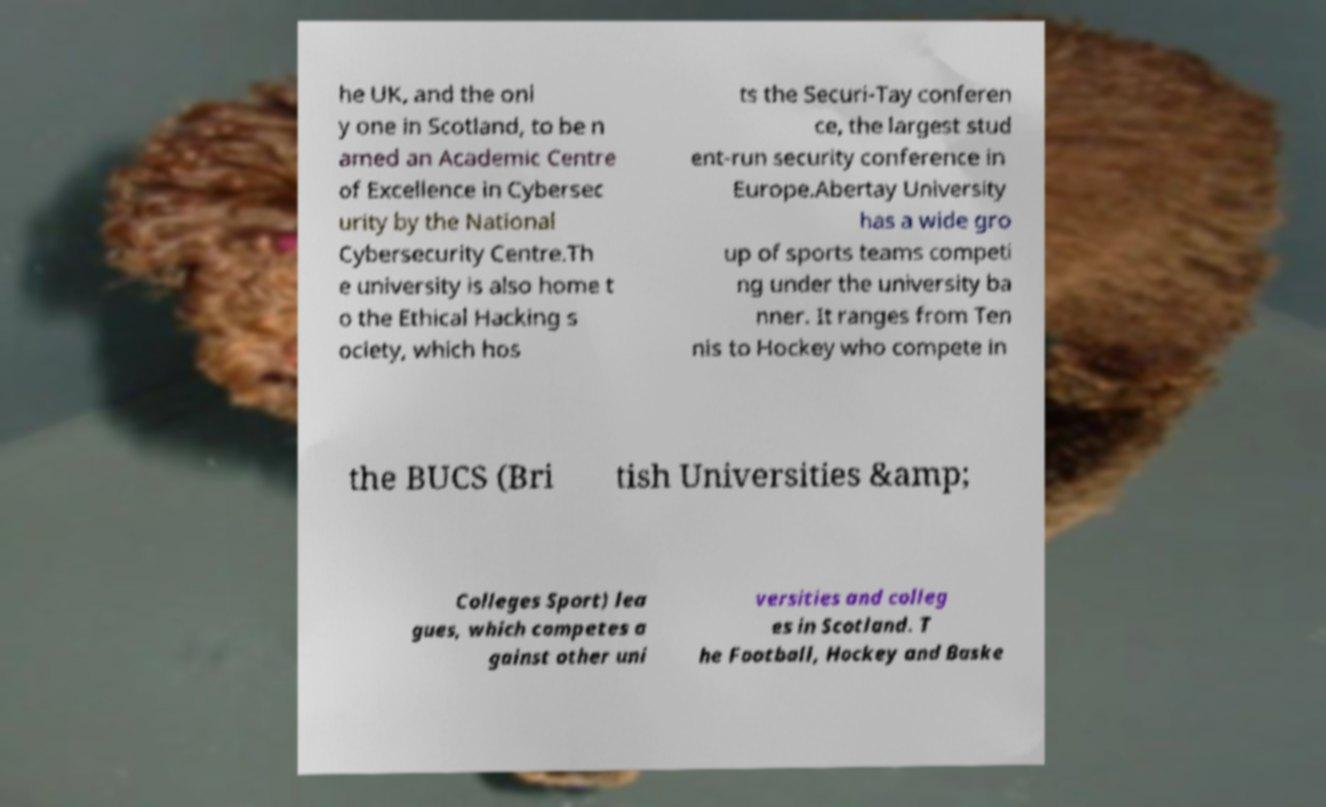Can you read and provide the text displayed in the image?This photo seems to have some interesting text. Can you extract and type it out for me? he UK, and the onl y one in Scotland, to be n amed an Academic Centre of Excellence in Cybersec urity by the National Cybersecurity Centre.Th e university is also home t o the Ethical Hacking s ociety, which hos ts the Securi-Tay conferen ce, the largest stud ent-run security conference in Europe.Abertay University has a wide gro up of sports teams competi ng under the university ba nner. It ranges from Ten nis to Hockey who compete in the BUCS (Bri tish Universities &amp; Colleges Sport) lea gues, which competes a gainst other uni versities and colleg es in Scotland. T he Football, Hockey and Baske 